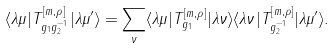Convert formula to latex. <formula><loc_0><loc_0><loc_500><loc_500>\langle \lambda \mu | T ^ { \left [ m , \rho \right ] } _ { g _ { 1 } g _ { 2 } ^ { - 1 } } | \lambda \mu ^ { \prime } \rangle = \sum _ { \nu } \langle \lambda \mu | T ^ { \left [ m , \rho \right ] } _ { g _ { 1 } } | \lambda \nu \rangle \langle \lambda \nu | T ^ { \left [ m , \rho \right ] } _ { g _ { 2 } ^ { - 1 } } | \lambda \mu ^ { \prime } \rangle .</formula> 